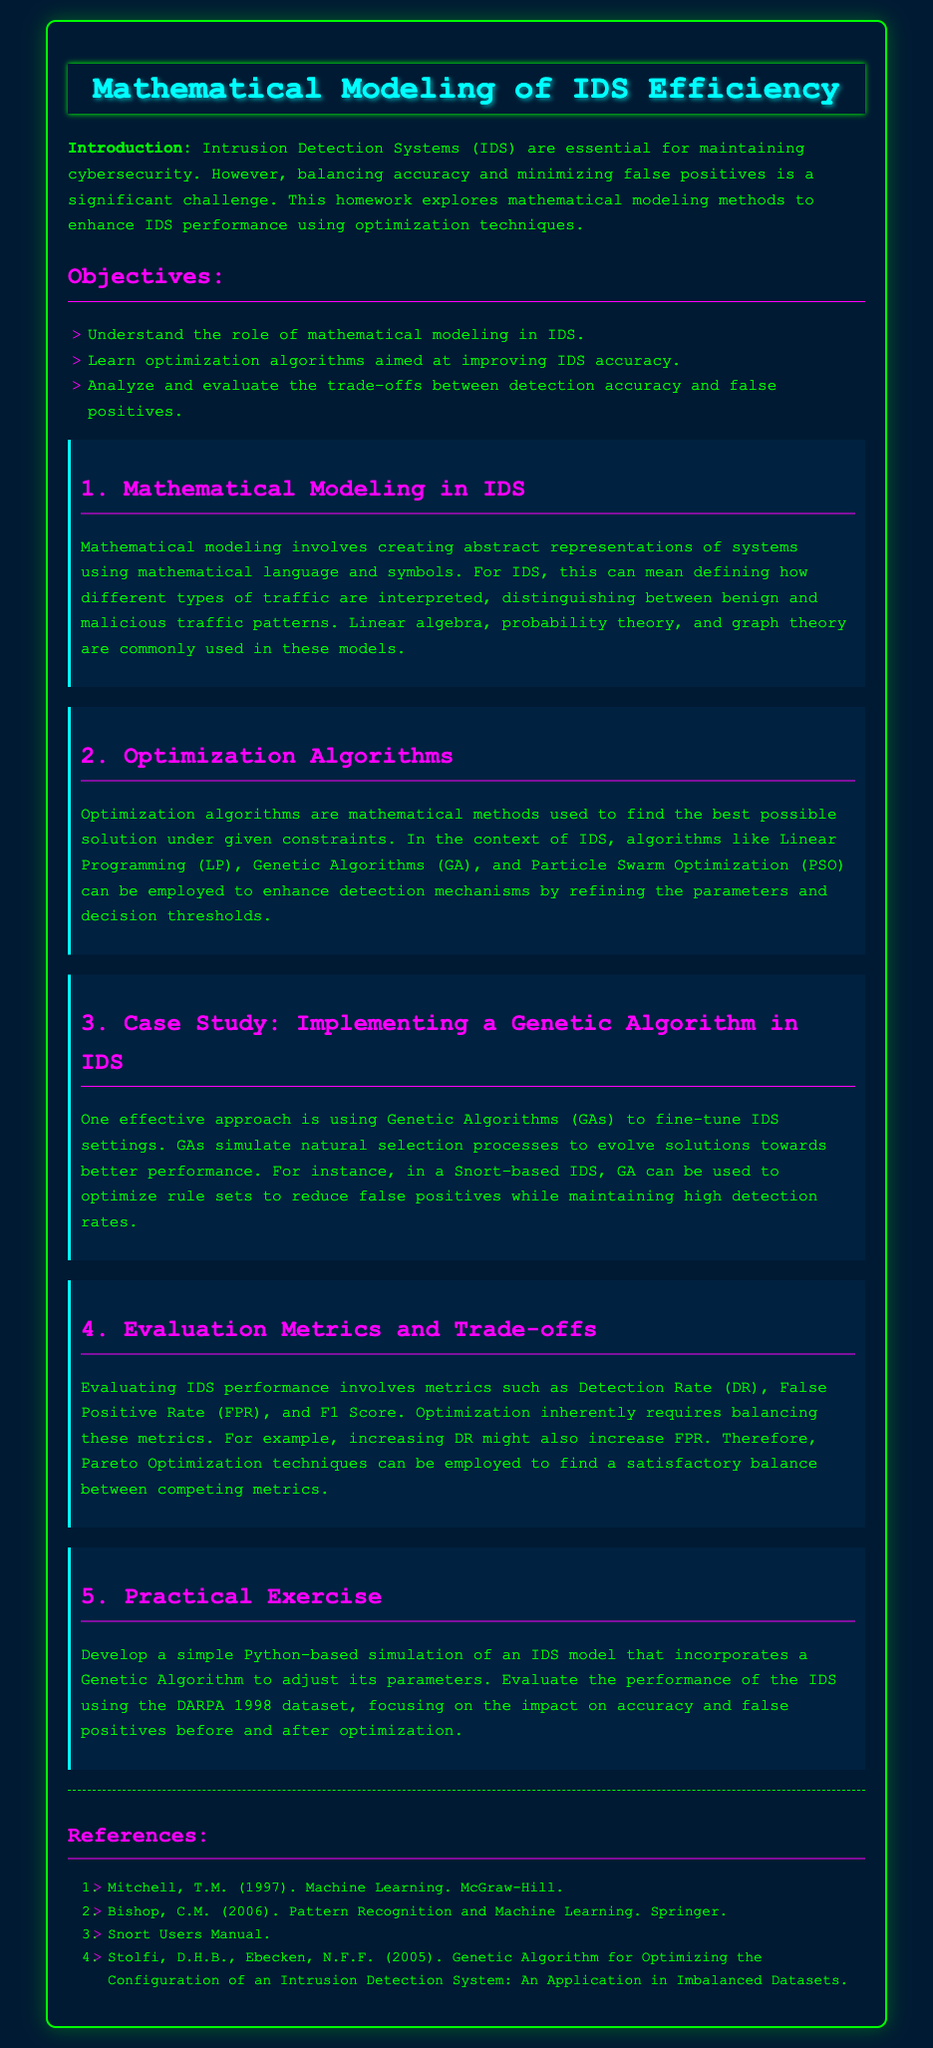what are the main objectives of the homework? The objectives are listed in the document under the "Objectives" section, highlighting the focus areas of the homework.
Answer: Understanding the role of mathematical modeling in IDS, learning optimization algorithms aimed at improving IDS accuracy, analyzing and evaluating the trade-offs between detection accuracy and false positives which case study is mentioned in the document? The case study relating to optimizing IDS settings using Genetic Algorithms is mentioned in the document.
Answer: Implementing a Genetic Algorithm in IDS what are the evaluation metrics used for IDS performance? The evaluation metrics are specified in the "Evaluation Metrics and Trade-offs" section, describing how performance can be assessed.
Answer: Detection Rate, False Positive Rate, F1 Score what mathematical methods are commonly used in mathematical modeling of IDS? This information is presented in the "Mathematical Modeling in IDS" section, listing the applicable methods used in the context.
Answer: Linear algebra, probability theory, graph theory what optimization techniques are suggested in the homework? The document discusses several optimization algorithms, specifying the techniques recommended for improving IDS performance.
Answer: Linear Programming, Genetic Algorithms, Particle Swarm Optimization 